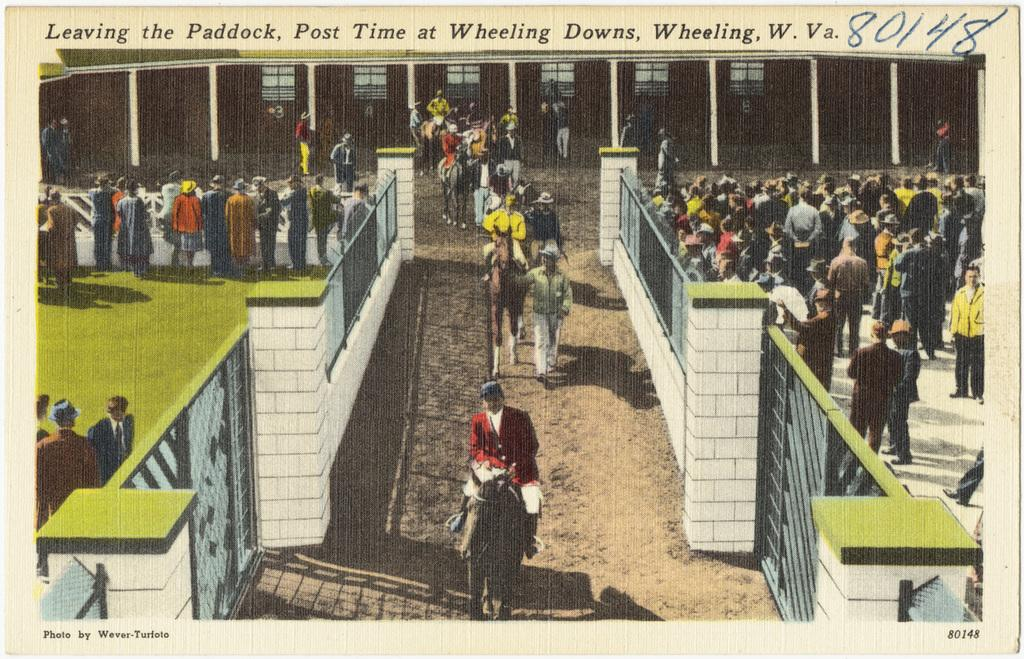<image>
Write a terse but informative summary of the picture. Old photo of horses and riders leaving the paddock at Wheeling Downs. 